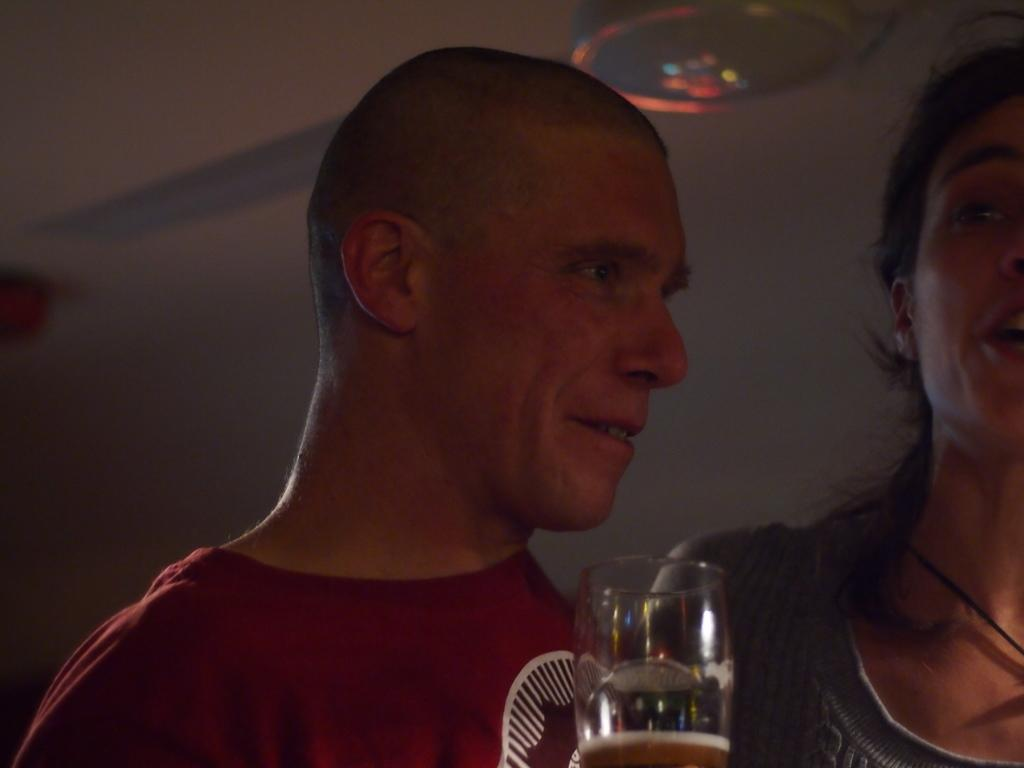What is the gender of the person in the image? There is a man in the image. What is the man wearing? The man is wearing a t-shirt. Is there anyone else in the image? Yes, there is a woman in the image. How is the woman positioned in relation to the man? The woman is standing near the man. What type of glass can be seen in the image? There is a wine glass in the image. What device is visible in the image? There is a fan visible in the image. What is the purpose of the farm in the image? There is no farm present in the image. In which direction is the north located in the image? The concept of direction, such as north, is not relevant to the image, as it does not depict a specific location or landscape. 